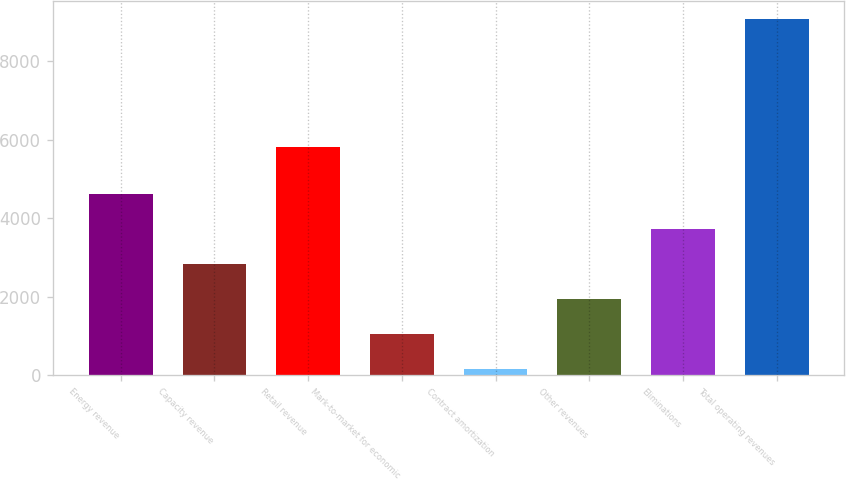Convert chart to OTSL. <chart><loc_0><loc_0><loc_500><loc_500><bar_chart><fcel>Energy revenue<fcel>Capacity revenue<fcel>Retail revenue<fcel>Mark-to-market for economic<fcel>Contract amortization<fcel>Other revenues<fcel>Eliminations<fcel>Total operating revenues<nl><fcel>4619<fcel>2835<fcel>5807<fcel>1051<fcel>159<fcel>1943<fcel>3727<fcel>9079<nl></chart> 